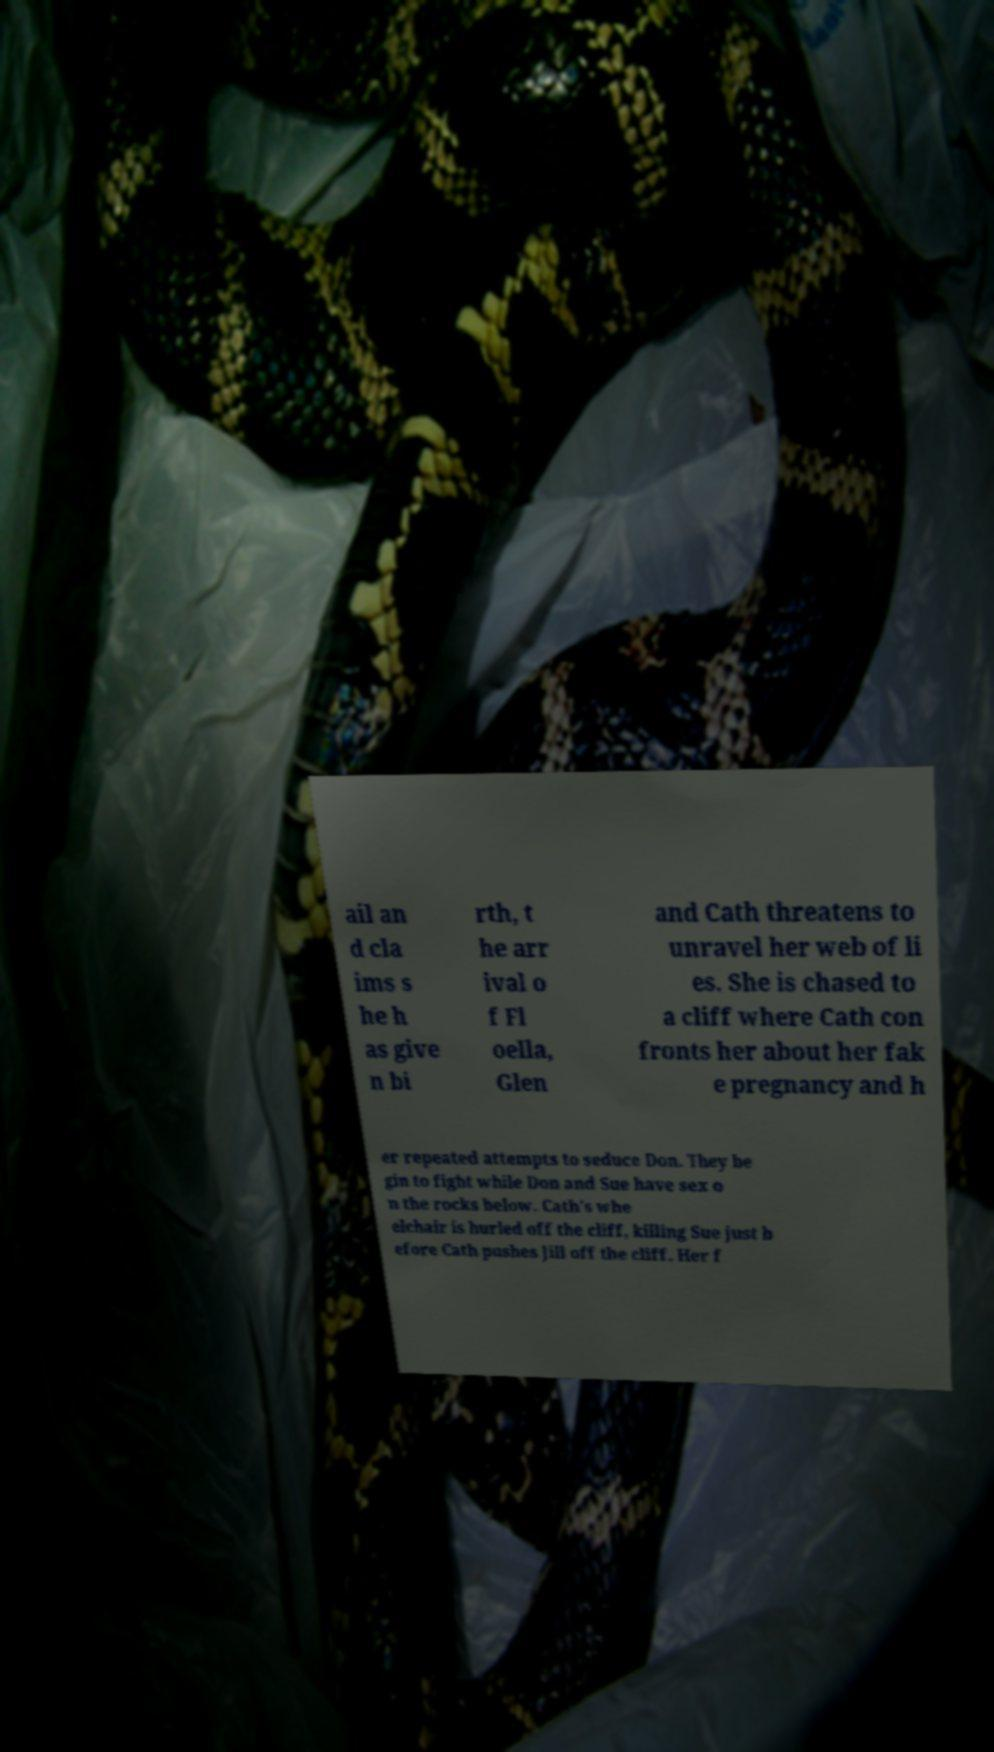Please identify and transcribe the text found in this image. ail an d cla ims s he h as give n bi rth, t he arr ival o f Fl oella, Glen and Cath threatens to unravel her web of li es. She is chased to a cliff where Cath con fronts her about her fak e pregnancy and h er repeated attempts to seduce Don. They be gin to fight while Don and Sue have sex o n the rocks below. Cath's whe elchair is hurled off the cliff, killing Sue just b efore Cath pushes Jill off the cliff. Her f 